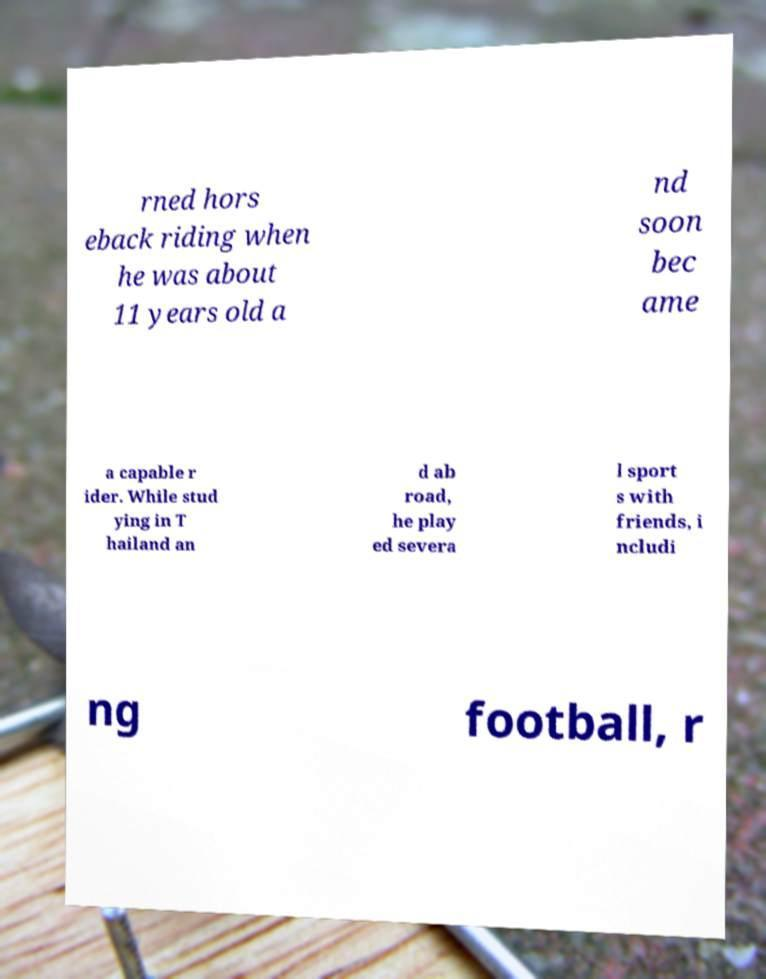Please identify and transcribe the text found in this image. rned hors eback riding when he was about 11 years old a nd soon bec ame a capable r ider. While stud ying in T hailand an d ab road, he play ed severa l sport s with friends, i ncludi ng football, r 